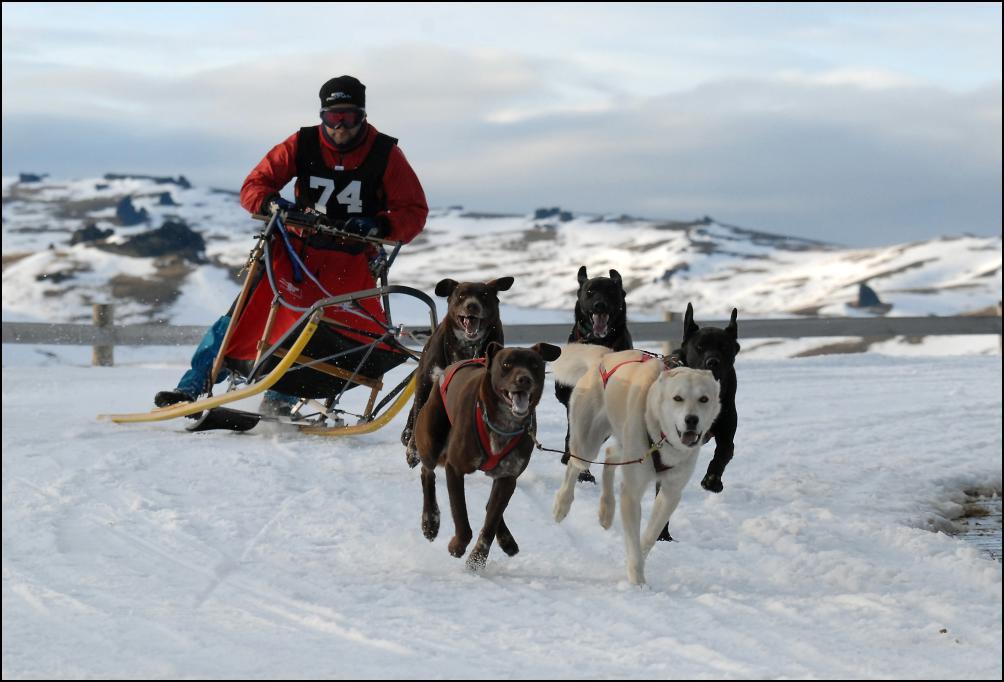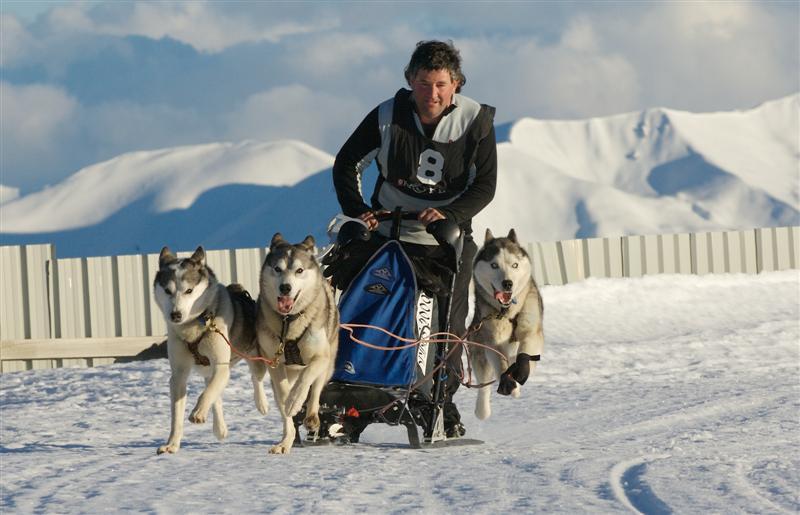The first image is the image on the left, the second image is the image on the right. Assess this claim about the two images: "At least two dogs are in the foreground leading a dog sled in each image, and each image shows a dog team heading toward the camera.". Correct or not? Answer yes or no. Yes. The first image is the image on the left, the second image is the image on the right. Evaluate the accuracy of this statement regarding the images: "One image in the pair shows multiple dog sleds and the other shows a single dog sled with multiple people riding.". Is it true? Answer yes or no. No. 